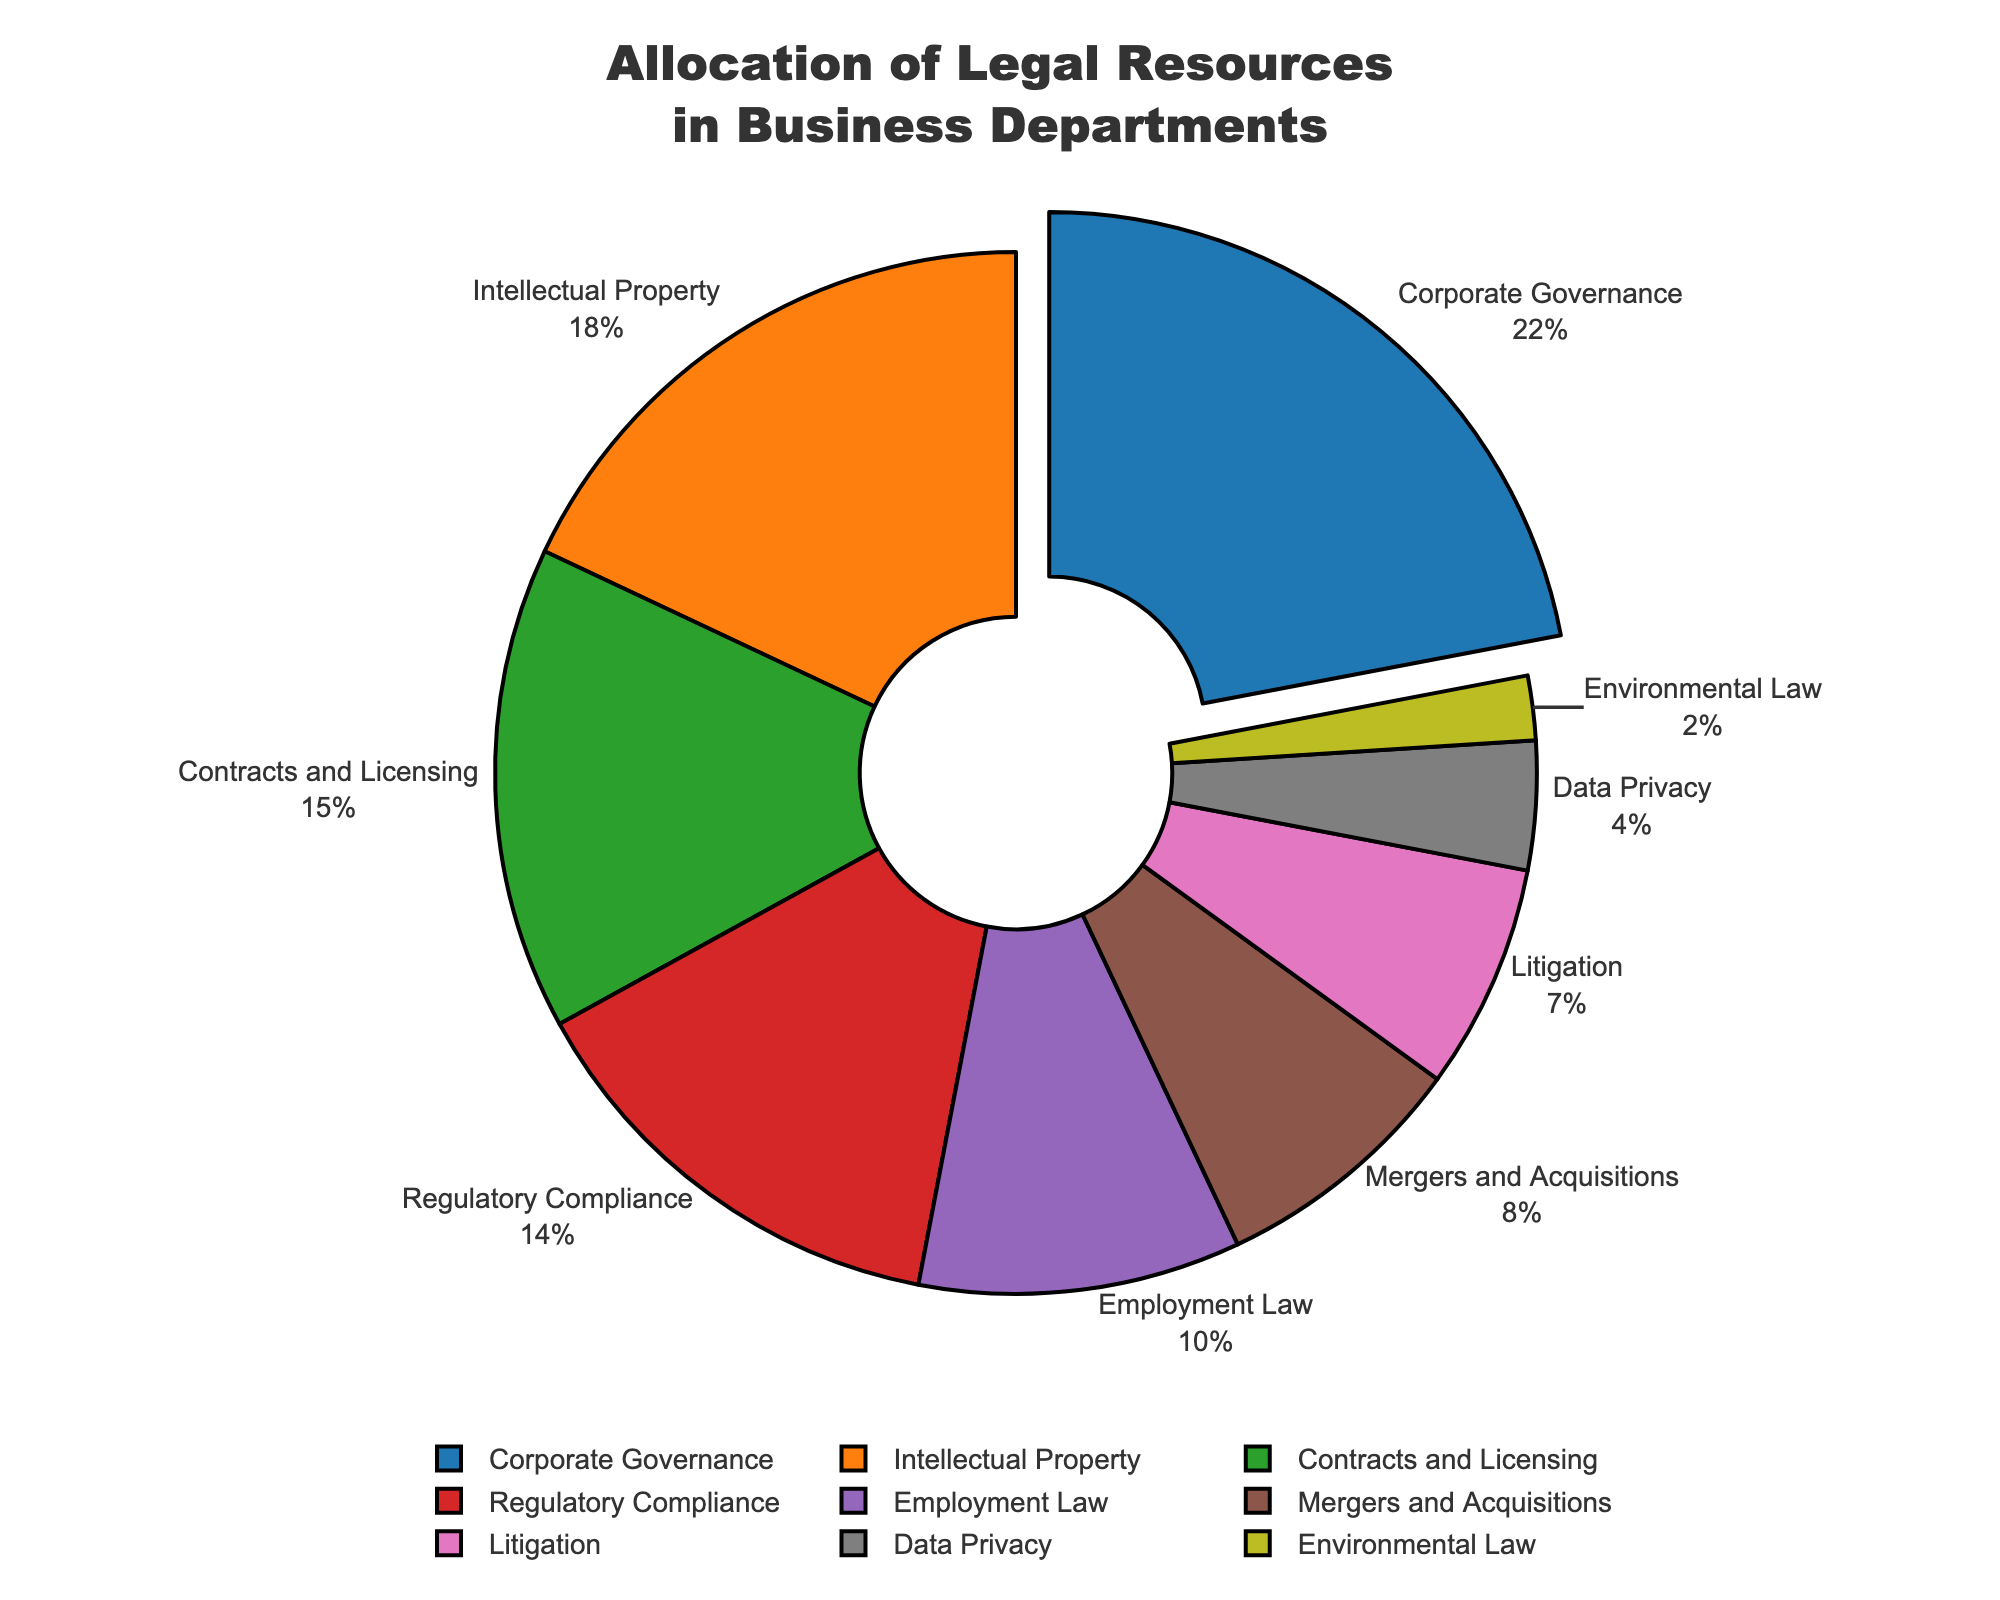What percentage of legal resources is allocated to Intellectual Property and Environmental Law combined? Combine the percentage values for Intellectual Property and Environmental Law: 18% (Intellectual Property) + 2% (Environmental Law) = 20%
Answer: 20% How much more percentage of legal resources is allocated to Corporate Governance compared to Litigation? Subtract the percentage for Litigation from Corporate Governance: 22% (Corporate Governance) - 7% (Litigation) = 15%
Answer: 15% Which department has the least allocation of legal resources? The pie chart shows that Environmental Law has the smallest slice, indicating it has the least percentage allocation.
Answer: Environmental Law Is the allocation for Contracts and Licensing greater than that for Regulatory Compliance? Compare the slices for Contracts and Licensing and Regulatory Compliance: Contracts and Licensing has 15%, and Regulatory Compliance has 14%. 15% is greater than 14%.
Answer: Yes Which department receives the highest allocation and what visual feature indicates this? Corporate Governance receives the highest allocation. This is visually indicated by its slice being pulled out from the rest of the pie.
Answer: Corporate Governance How do the allocations for Employment Law and Mergers and Acquisitions compare? Employment Law has 10% and Mergers and Acquisitions has 8%. Employment Law has a 2% higher allocation than Mergers and Acquisitions.
Answer: Employment Law What is the difference in allocation between Data Privacy and Litigation? Subtract the percentage for Data Privacy from Litigation: 7% (Litigation) - 4% (Data Privacy) = 3%
Answer: 3% Which color represents the department with the second-highest allocation of legal resources? The second-highest allocation is for Intellectual Property (18%). The color used for Intellectual Property is orange.
Answer: Orange How many departments have more than 10% allocation of legal resources? Identify slices with percentages greater than 10%: Corporate Governance (22%), Intellectual Property (18%), Contracts and Licensing (15%), Regulatory Compliance (14%), and Employment Law (10%=exactly 10%). Total is 4 departments.
Answer: 4 